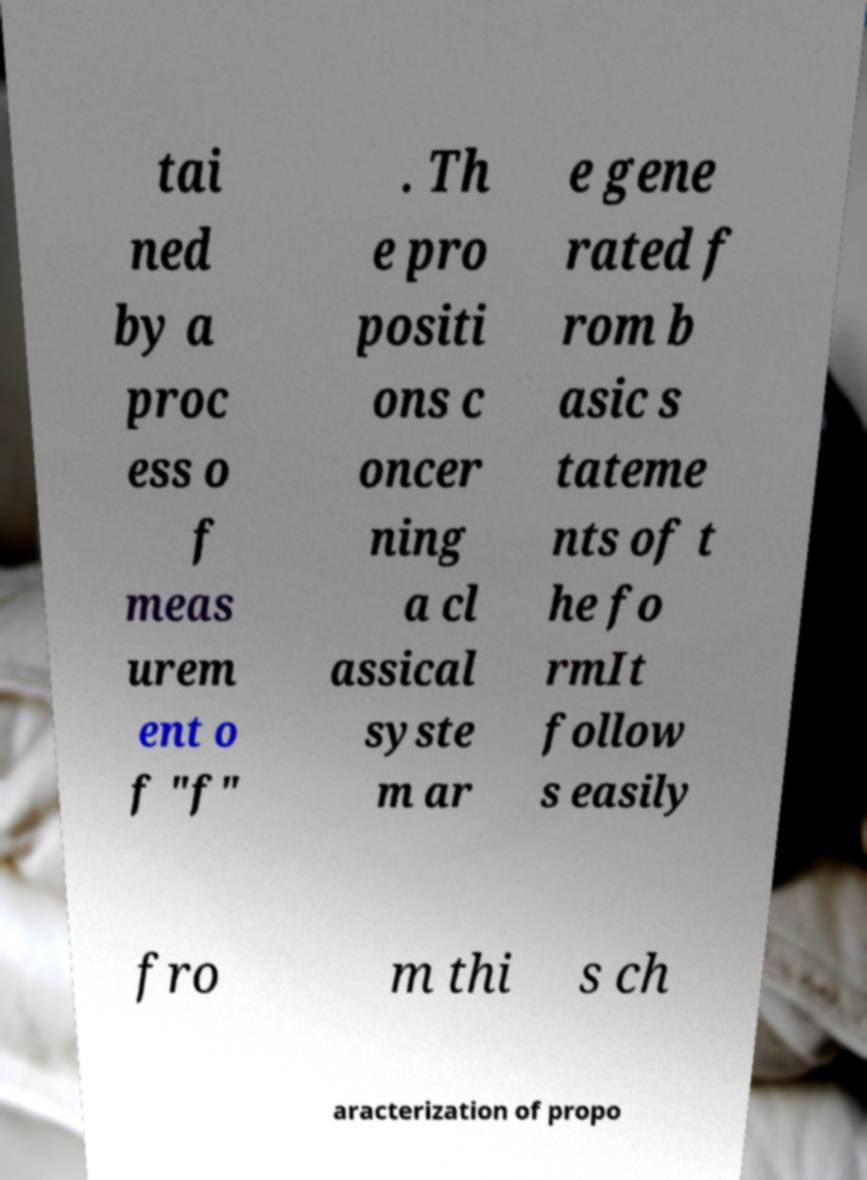For documentation purposes, I need the text within this image transcribed. Could you provide that? tai ned by a proc ess o f meas urem ent o f "f" . Th e pro positi ons c oncer ning a cl assical syste m ar e gene rated f rom b asic s tateme nts of t he fo rmIt follow s easily fro m thi s ch aracterization of propo 